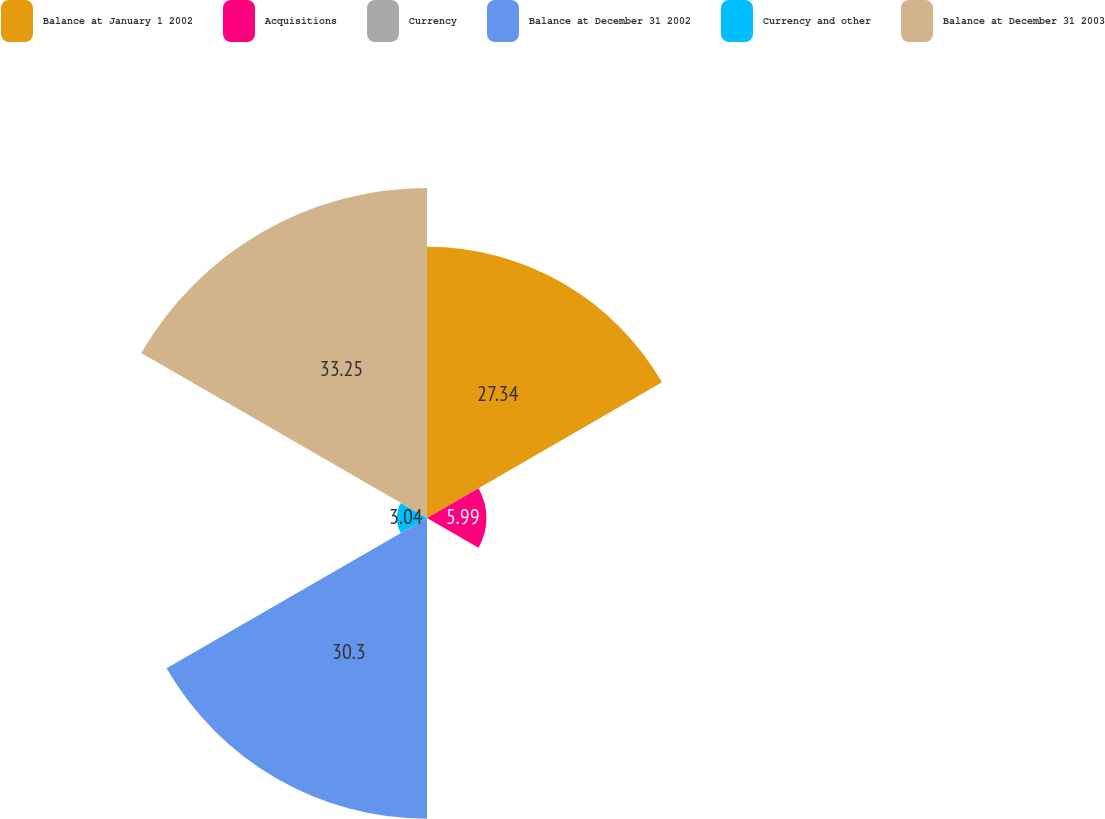<chart> <loc_0><loc_0><loc_500><loc_500><pie_chart><fcel>Balance at January 1 2002<fcel>Acquisitions<fcel>Currency<fcel>Balance at December 31 2002<fcel>Currency and other<fcel>Balance at December 31 2003<nl><fcel>27.34%<fcel>5.99%<fcel>0.08%<fcel>30.3%<fcel>3.04%<fcel>33.25%<nl></chart> 